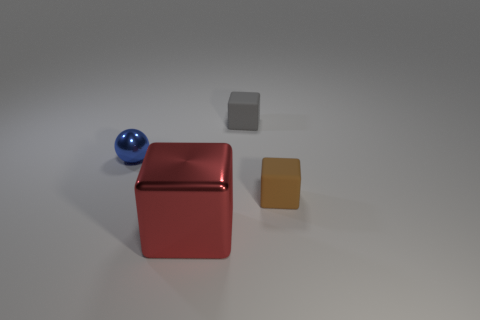The cube that is behind the small brown object is what color?
Your answer should be compact. Gray. What size is the cube that is behind the big block and to the left of the brown rubber block?
Your answer should be very brief. Small. How many rubber cubes are the same size as the blue shiny sphere?
Give a very brief answer. 2. There is a tiny gray thing that is the same shape as the large red object; what is its material?
Your answer should be compact. Rubber. Is the shape of the tiny brown rubber object the same as the big object?
Ensure brevity in your answer.  Yes. There is a blue thing; how many rubber blocks are in front of it?
Give a very brief answer. 1. There is a small blue shiny object behind the tiny matte object that is in front of the ball; what shape is it?
Your answer should be very brief. Sphere. What shape is the other blue thing that is the same material as the large object?
Your answer should be very brief. Sphere. There is a shiny object that is behind the brown rubber thing; is it the same size as the thing that is in front of the brown object?
Offer a very short reply. No. What is the shape of the large red metal thing that is in front of the metallic ball?
Offer a terse response. Cube. 